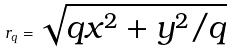<formula> <loc_0><loc_0><loc_500><loc_500>r _ { q } = \sqrt { q x ^ { 2 } + y ^ { 2 } / q }</formula> 